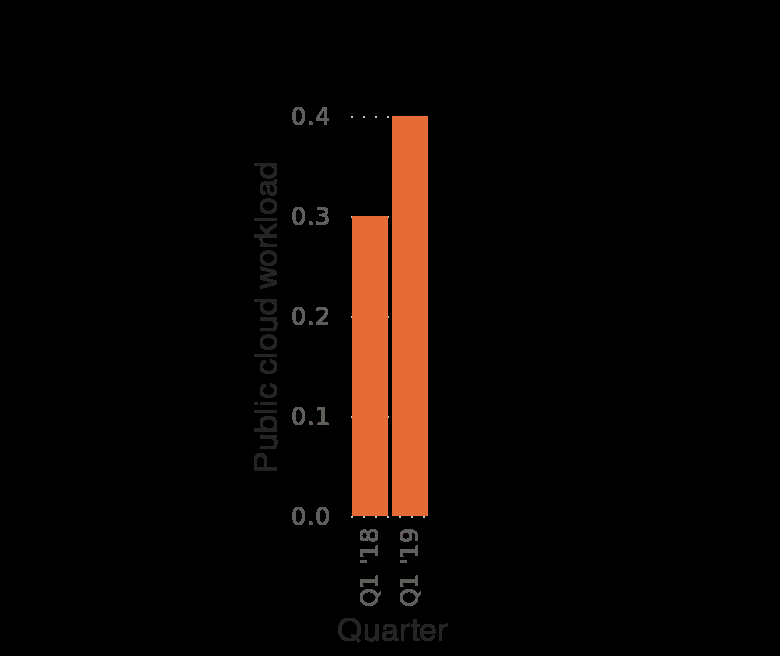<image>
What is the unit of measurement for the Quarterly revenue in the bar diagram? The Quarterly revenue is measured in billion U.S. dollars in the bar diagram. please summary the statistics and relations of the chart The chart shows that Q1 of ‘18 was less at 0.3 public cloud workload than Q1 of ‘19 with 0.4 public cloud workload There was a 0.1 public cloud workload difference between Q1 in ‘18 and ‘19. 